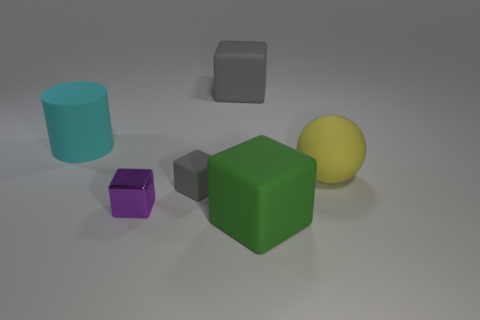There is a purple thing that is the same shape as the green rubber thing; what is its size?
Your response must be concise. Small. What is the shape of the thing in front of the metal cube?
Offer a very short reply. Cube. What is the gray block that is on the left side of the gray thing that is to the right of the small gray object made of?
Give a very brief answer. Rubber. Is the number of green matte things behind the big green cube greater than the number of small gray objects?
Your answer should be very brief. No. What number of other objects are the same color as the small matte object?
Keep it short and to the point. 1. What shape is the cyan matte thing that is the same size as the yellow rubber ball?
Offer a terse response. Cylinder. What number of shiny cubes are right of the gray rubber thing in front of the gray matte thing behind the big cyan cylinder?
Give a very brief answer. 0. What number of rubber objects are either tiny things or big cyan objects?
Provide a succinct answer. 2. What color is the cube that is both right of the purple thing and in front of the tiny gray matte cube?
Make the answer very short. Green. There is a rubber object that is right of the green matte thing; does it have the same size as the cyan matte thing?
Make the answer very short. Yes. 